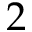Convert formula to latex. <formula><loc_0><loc_0><loc_500><loc_500>2</formula> 